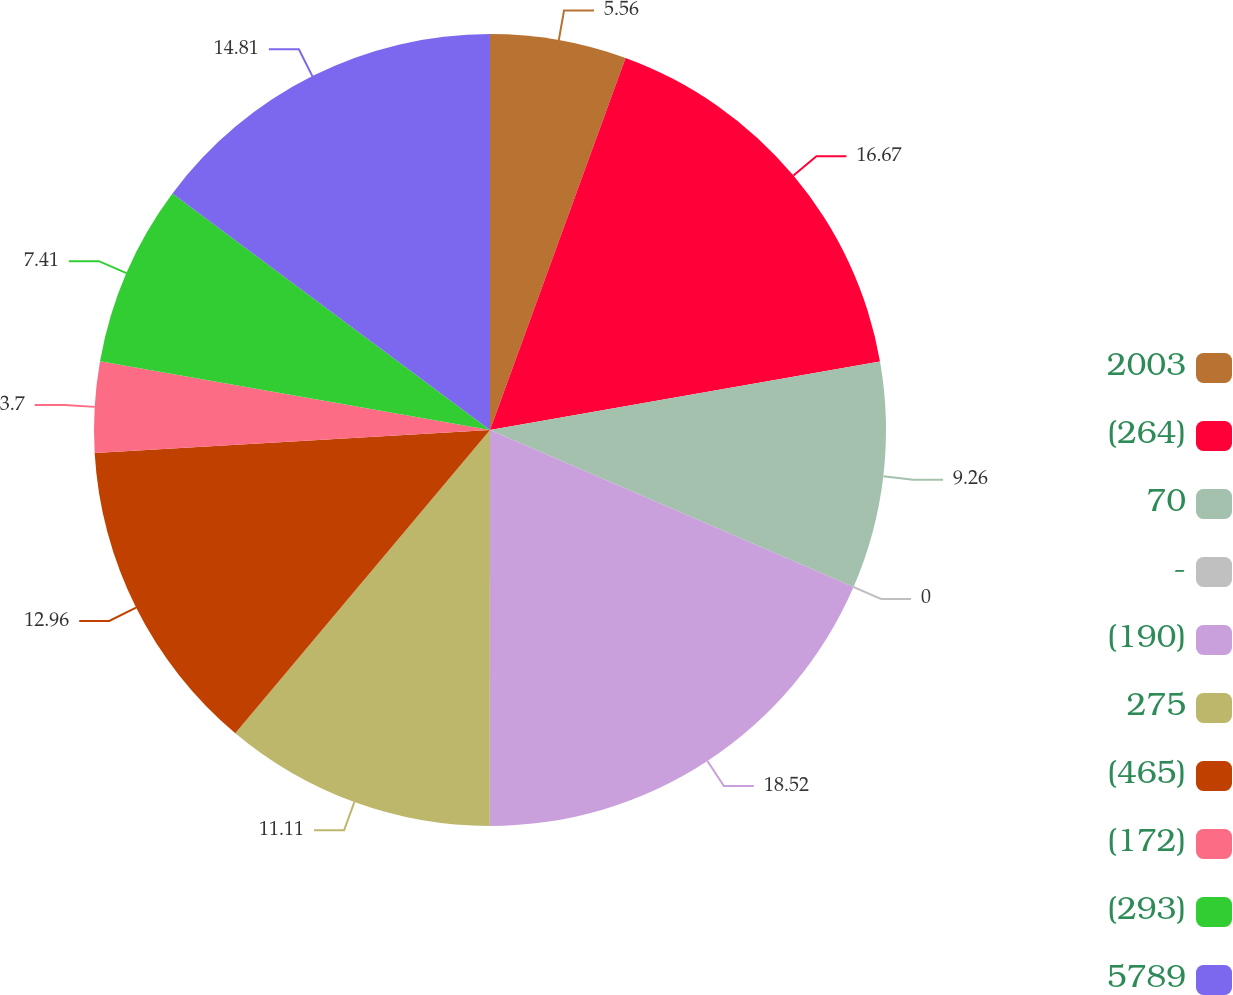<chart> <loc_0><loc_0><loc_500><loc_500><pie_chart><fcel>2003<fcel>(264)<fcel>70<fcel>-<fcel>(190)<fcel>275<fcel>(465)<fcel>(172)<fcel>(293)<fcel>5789<nl><fcel>5.56%<fcel>16.67%<fcel>9.26%<fcel>0.0%<fcel>18.52%<fcel>11.11%<fcel>12.96%<fcel>3.7%<fcel>7.41%<fcel>14.81%<nl></chart> 